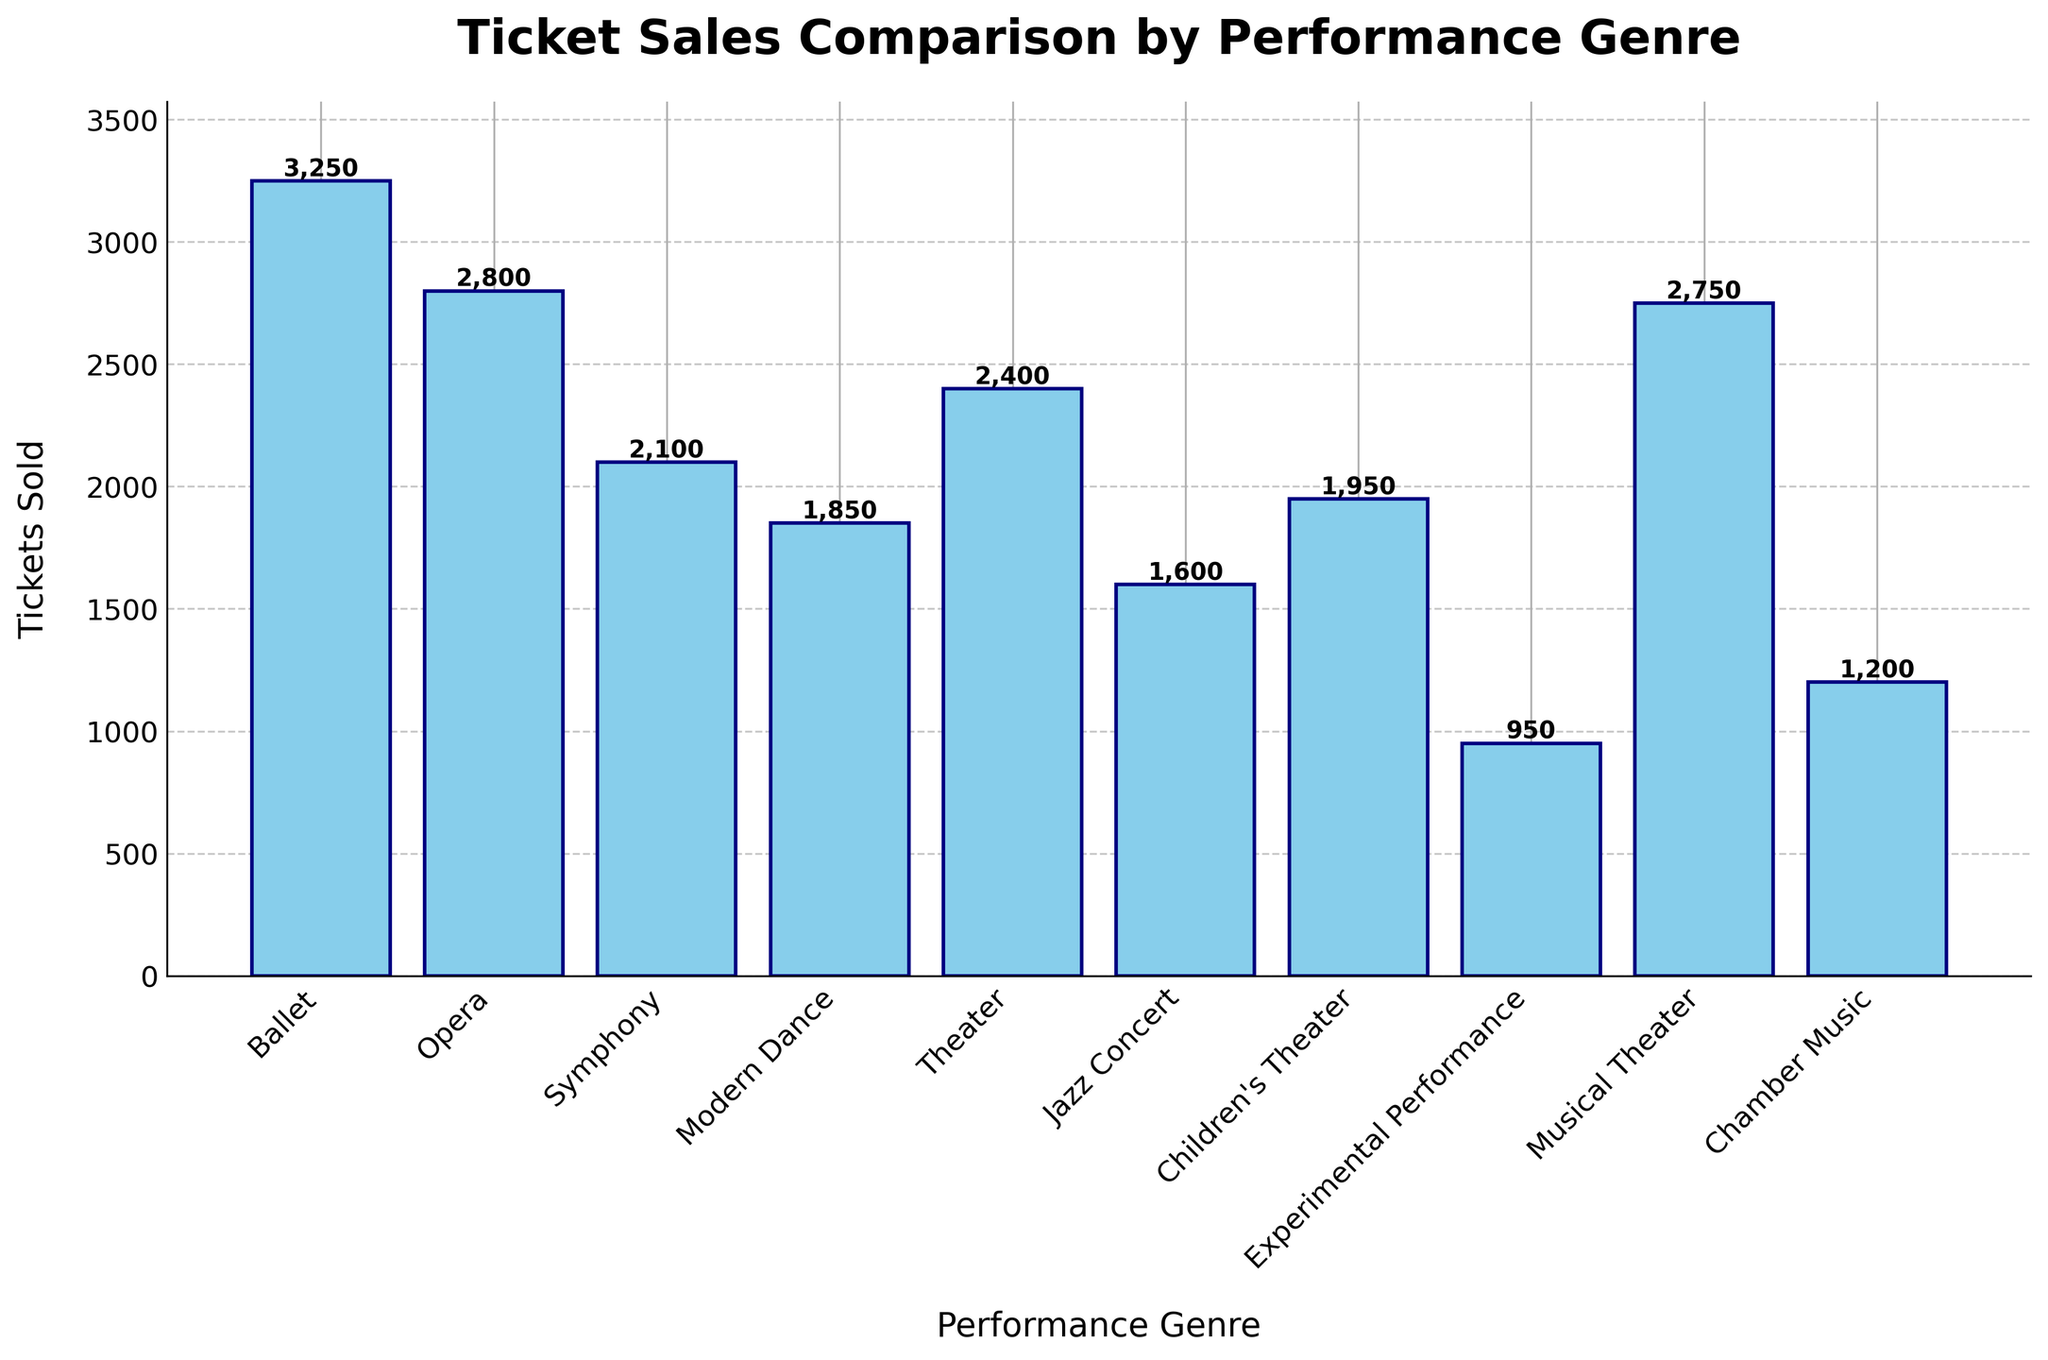Which performance genre sold the most tickets? Identify the tallest bar in the bar chart. The tallest bar represents the genre with the most ticket sales.
Answer: Ballet What's the difference in ticket sales between Opera and Symphony? Find the height of the bars representing Opera and Symphony. Subtract the height of Symphony from Opera: 2800 - 2100.
Answer: 700 Which genre sold fewer tickets: Jazz Concert or Children's Theater? Compare the heights of the bars for Jazz Concert and Children's Theater. The shorter bar indicates fewer tickets sold.
Answer: Jazz Concert How many tickets were sold in total for Ballet, Opera, and Musical Theater combined? Add the heights of the bars for Ballet, Opera, and Musical Theater: 3250 + 2800 + 2750.
Answer: 8800 What is the average number of tickets sold across all genres? Sum the heights of all bars and divide by the number of genres: (3250 + 2800 + 2100 + 1850 + 2400 + 1600 + 1950 + 950 + 2750 + 1200) / 10.
Answer: 2085 Is Modern Dance ticket sales greater than Chamber Music and Jazz Concert combined? Add the heights of the bars for Chamber Music and Jazz Concert: 1200 + 1600 = 2800. Compare this with the height of the Modern Dance bar. 1850 < 2800, so Modern Dance is less.
Answer: No What's the sum of tickets sold for Theater and Children's Theater? Add the heights of the bars for Theater and Children's Theater: 2400 + 1950.
Answer: 4350 Which two genres have the closest ticket sales numbers? Compare the heights of all the bars to find the pair with the smallest difference. Opera (2800) and Musical Theater (2750) have a difference of 50.
Answer: Opera and Musical Theater How much more popular was Ballet compared to Experimental Performance? Subtract the height of the Experimental Performance bar from the Ballet bar: 3250 - 950.
Answer: 2300 What is the median number of tickets sold across all genres? List and sort the ticket sales: 950, 1200, 1600, 1850, 1950, 2100, 2400, 2750, 2800, 3250. The median is the average of the 5th and 6th values: (1950 + 2100) / 2.
Answer: 2025 